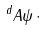Convert formula to latex. <formula><loc_0><loc_0><loc_500><loc_500>^ { d } { A \psi } { \, \cdot \, }</formula> 